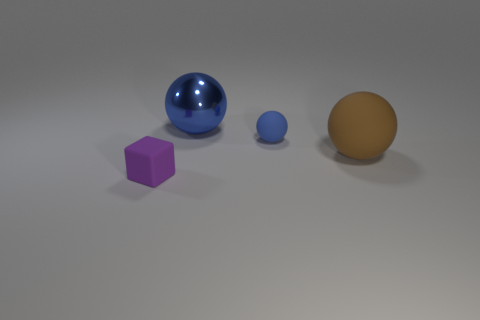Do the tiny sphere and the shiny sphere have the same color?
Make the answer very short. Yes. The matte object that is behind the small purple cube and left of the large brown sphere has what shape?
Your answer should be very brief. Sphere. What is the color of the sphere that is made of the same material as the large brown thing?
Offer a terse response. Blue. Is the number of large things in front of the shiny thing the same as the number of blue spheres?
Your response must be concise. No. What shape is the blue thing that is the same size as the matte cube?
Your response must be concise. Sphere. What number of other things are the same shape as the large matte thing?
Provide a short and direct response. 2. Does the purple cube have the same size as the matte sphere that is to the left of the large matte object?
Offer a very short reply. Yes. What number of things are small objects in front of the tiny blue thing or tiny green matte spheres?
Make the answer very short. 1. The matte thing that is to the left of the metal thing has what shape?
Ensure brevity in your answer.  Cube. Are there an equal number of small purple objects that are to the right of the brown object and blue rubber balls that are on the right side of the tiny purple object?
Ensure brevity in your answer.  No. 